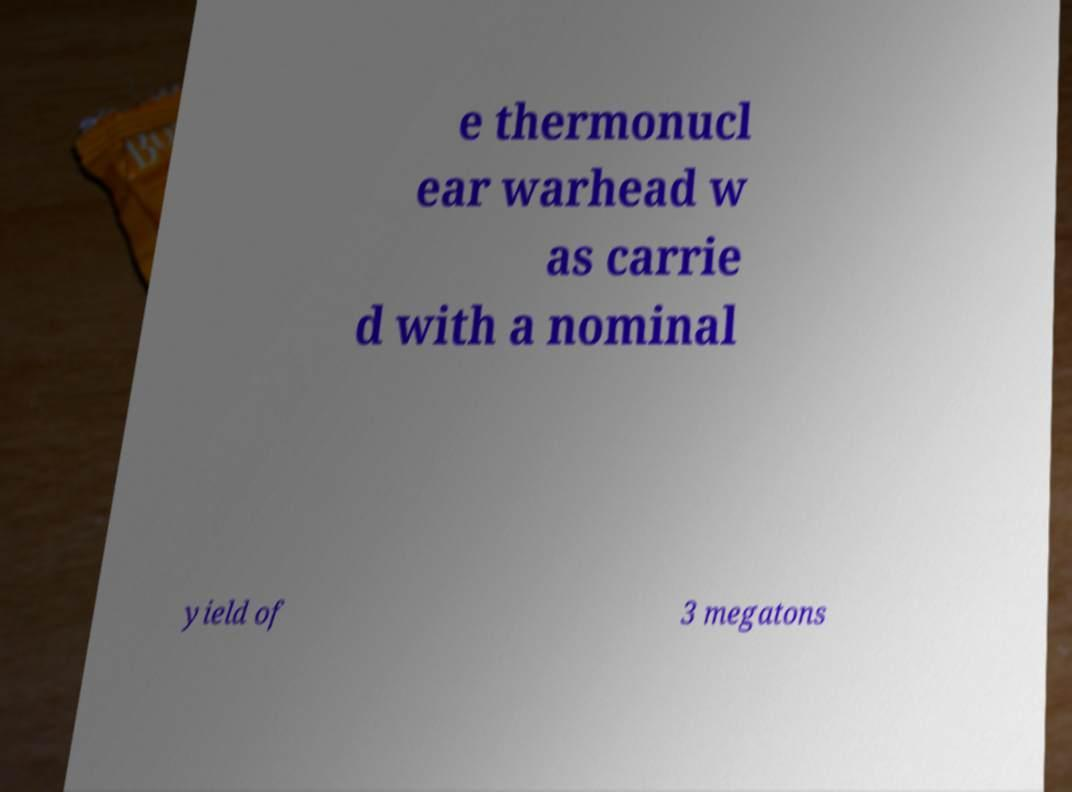Can you read and provide the text displayed in the image?This photo seems to have some interesting text. Can you extract and type it out for me? e thermonucl ear warhead w as carrie d with a nominal yield of 3 megatons 